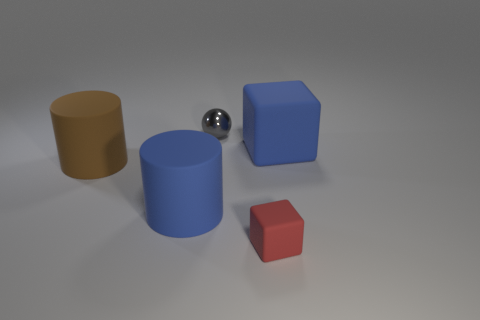Add 4 small gray shiny spheres. How many objects exist? 9 Subtract 0 yellow spheres. How many objects are left? 5 Subtract all cylinders. How many objects are left? 3 Subtract all big cylinders. Subtract all small gray objects. How many objects are left? 2 Add 3 gray shiny objects. How many gray shiny objects are left? 4 Add 4 large red metallic spheres. How many large red metallic spheres exist? 4 